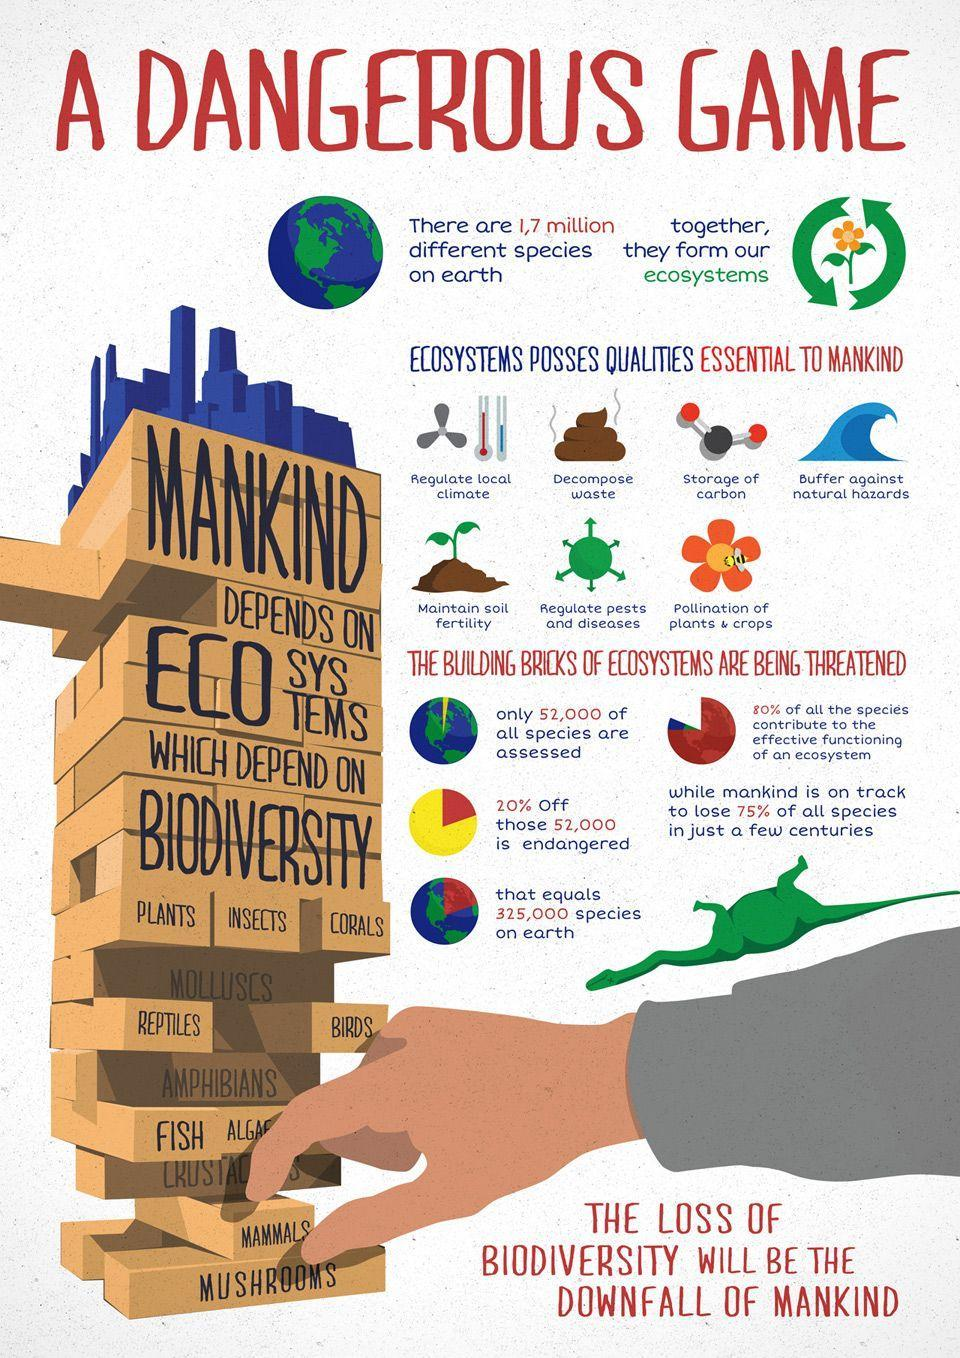Calculate the number of endangered species from the 52,000 species assessed?
Answer the question with a short phrase. 10,400 species To which building block do humans belong, Amphibians, Molluscs, Mammals, or Reptiles? Mammals 